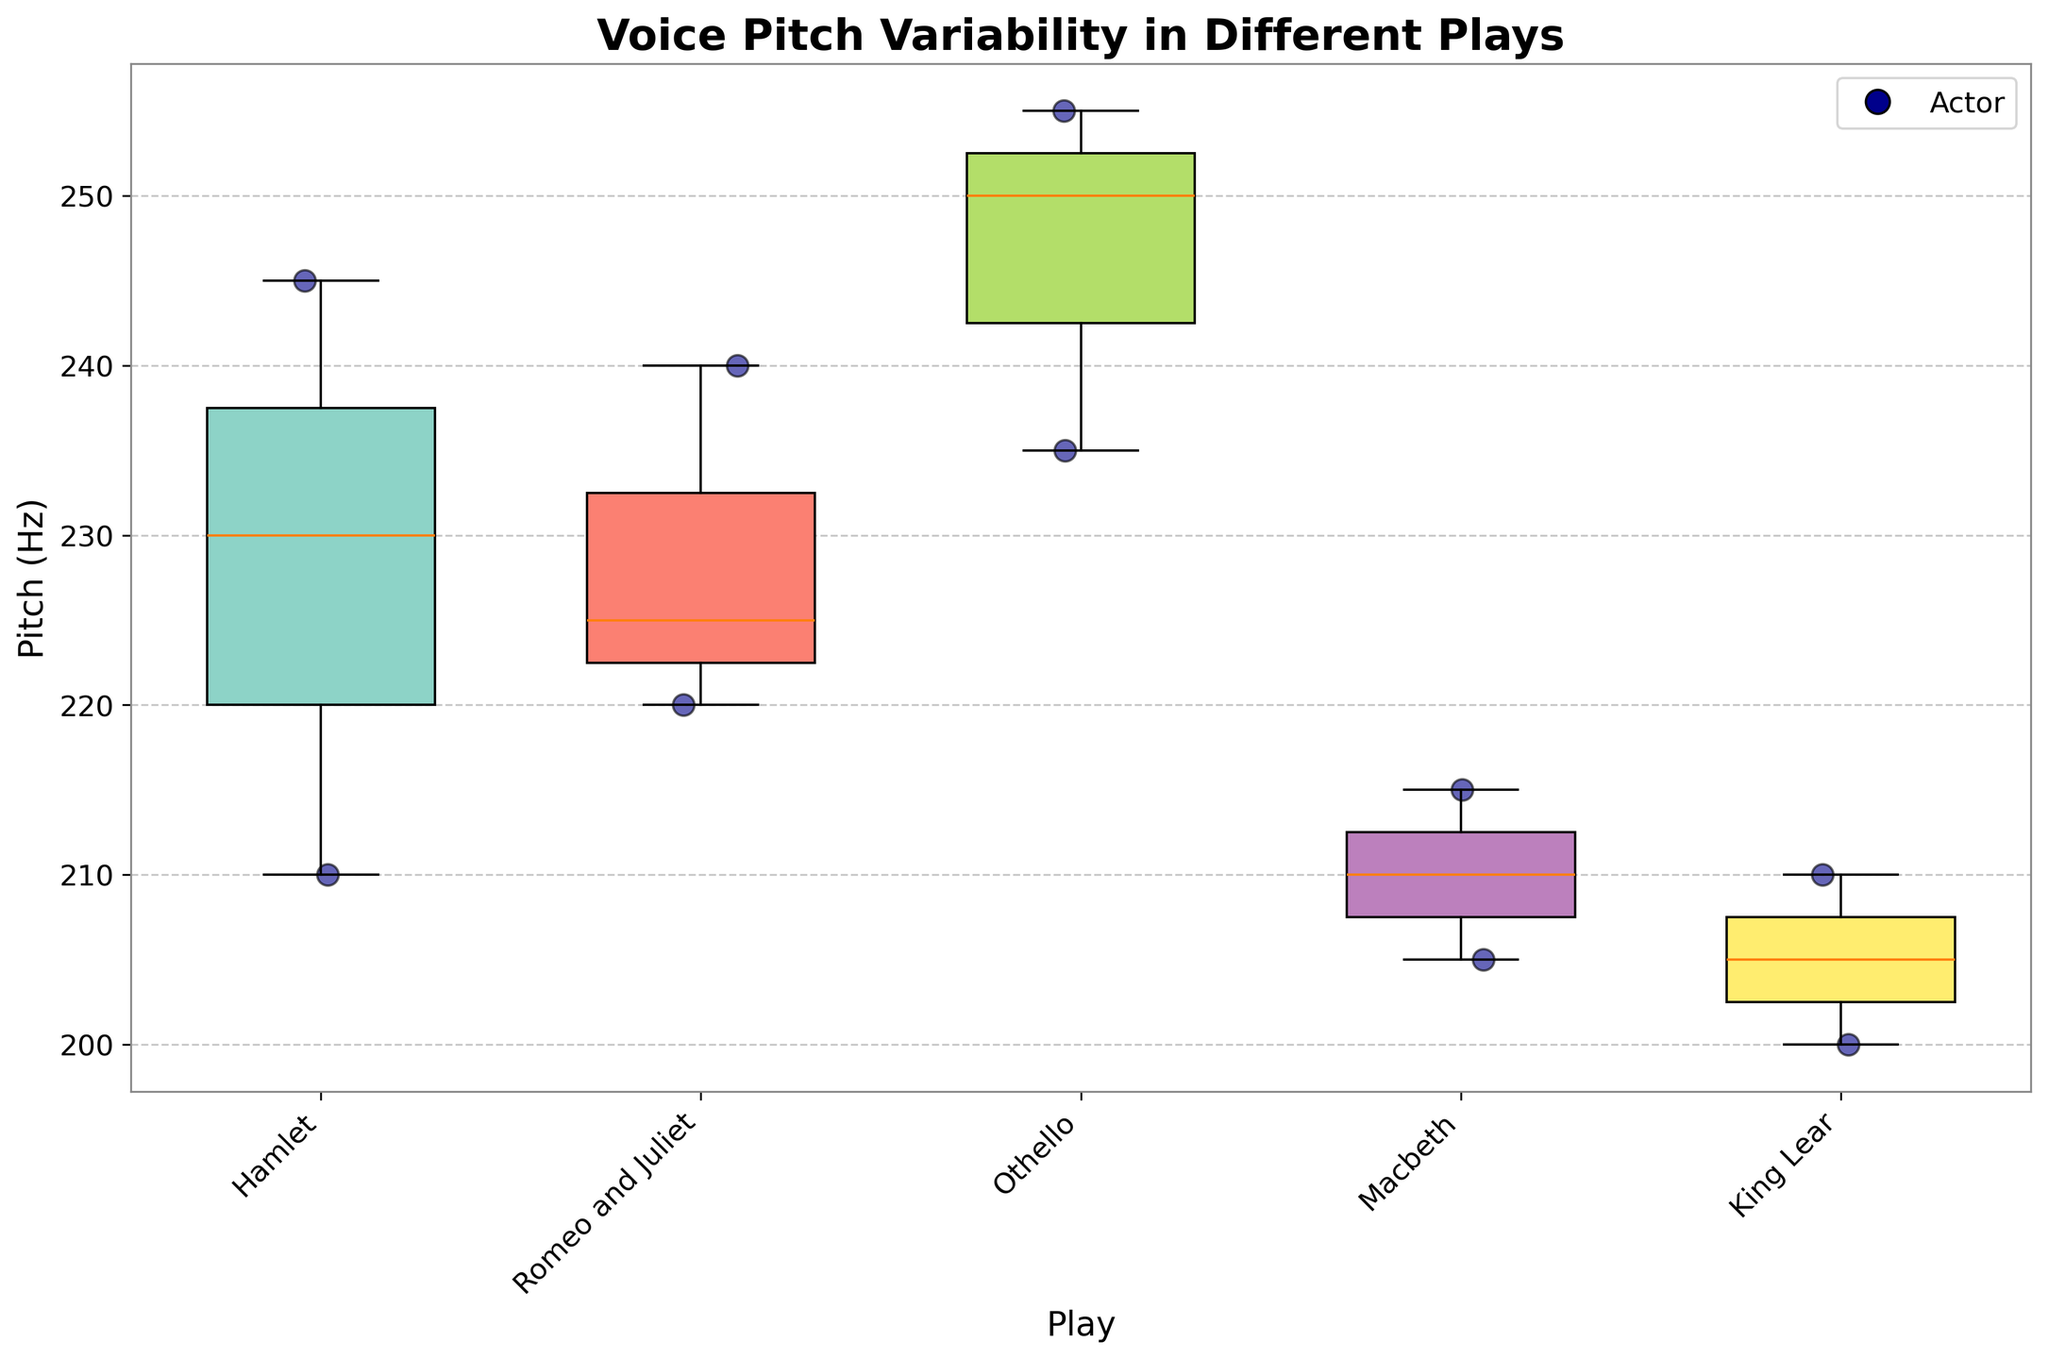What is the title of the plot? The title of the plot is usually displayed at the top, and in this case, the title reads "Voice Pitch Variability in Different Plays."
Answer: Voice Pitch Variability in Different Plays How many different plays are analyzed in the plot? The x-axis labels represent different plays, and there are five distinct labels.
Answer: Five plays Which play shows the highest median pitch? The median is represented by the line inside each box, and we compare the medians of each play. Othello has the highest median pitch.
Answer: Othello Which play has the widest range of pitch values? The range of each play can be determined by the height of the boxplot from the minimum to the maximum whisker. Othello has the widest range.
Answer: Othello Are there any plays with similar median pitch values? By comparing the medians inside the boxes, Hamlet and Romeo and Juliet have almost similar median pitch values.
Answer: Hamlet and Romeo and Juliet Which play has the smallest interquartile range (IQR)? The IQR is the range of the box (from the bottom to the top of the box). King Lear has the smallest IQR.
Answer: King Lear Does John Doe appear to have a consistent pitch across different plays? By locating John Doe’s data points in each play (colored scatter points), we see variability. Therefore, his pitch is not consistent.
Answer: No What is the pitch range for Macbeth? The range can be found using the minimum and maximum whiskers. For Macbeth, the range is from the bottom (205 Hz) to the top (215 Hz).
Answer: 205 Hz to 215 Hz Is there a general trend in pitch values across all plays? Looking at the median lines across different boxes, it appears that pitch values generally vary without a consistent trend.
Answer: No consistent trend If you averaged the median pitches of Romeo and Juliet and Macbeth, what would it be? Find the median of Romeo and Juliet (around 220 Hz) and Macbeth (around 210 Hz) and calculate the average: (220+210)/2.
Answer: 215 Hz 